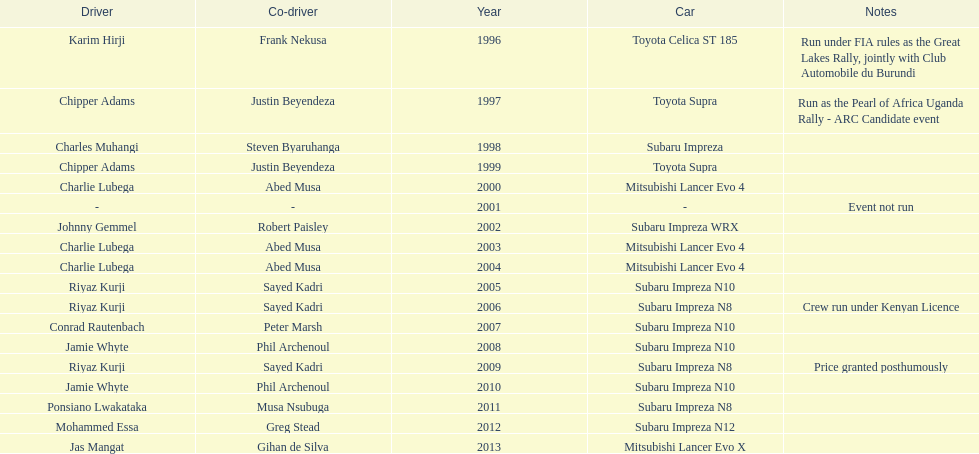Chipper adams and justin beyendeza have how mnay wins? 2. 